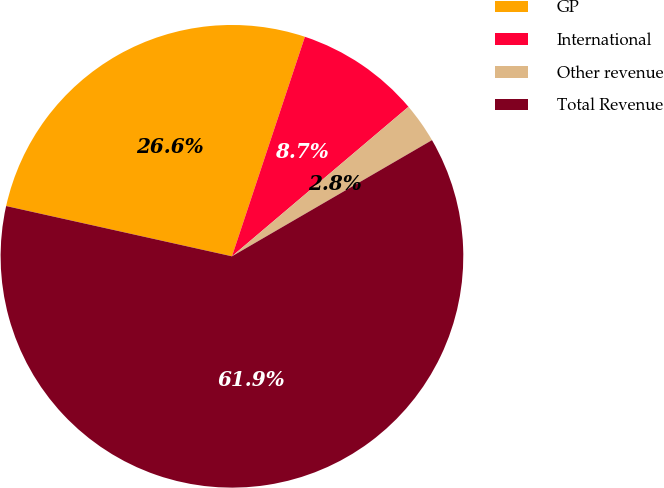Convert chart to OTSL. <chart><loc_0><loc_0><loc_500><loc_500><pie_chart><fcel>GP<fcel>International<fcel>Other revenue<fcel>Total Revenue<nl><fcel>26.62%<fcel>8.71%<fcel>2.81%<fcel>61.86%<nl></chart> 